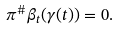<formula> <loc_0><loc_0><loc_500><loc_500>\label l { e q \colon e x t } \pi ^ { \# } \beta _ { t } ( \gamma ( t ) ) = 0 .</formula> 